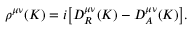<formula> <loc_0><loc_0><loc_500><loc_500>\rho ^ { \mu \nu } ( K ) = i \left [ D _ { R } ^ { \mu \nu } ( K ) - D _ { A } ^ { \mu \nu } ( K ) \right ] .</formula> 